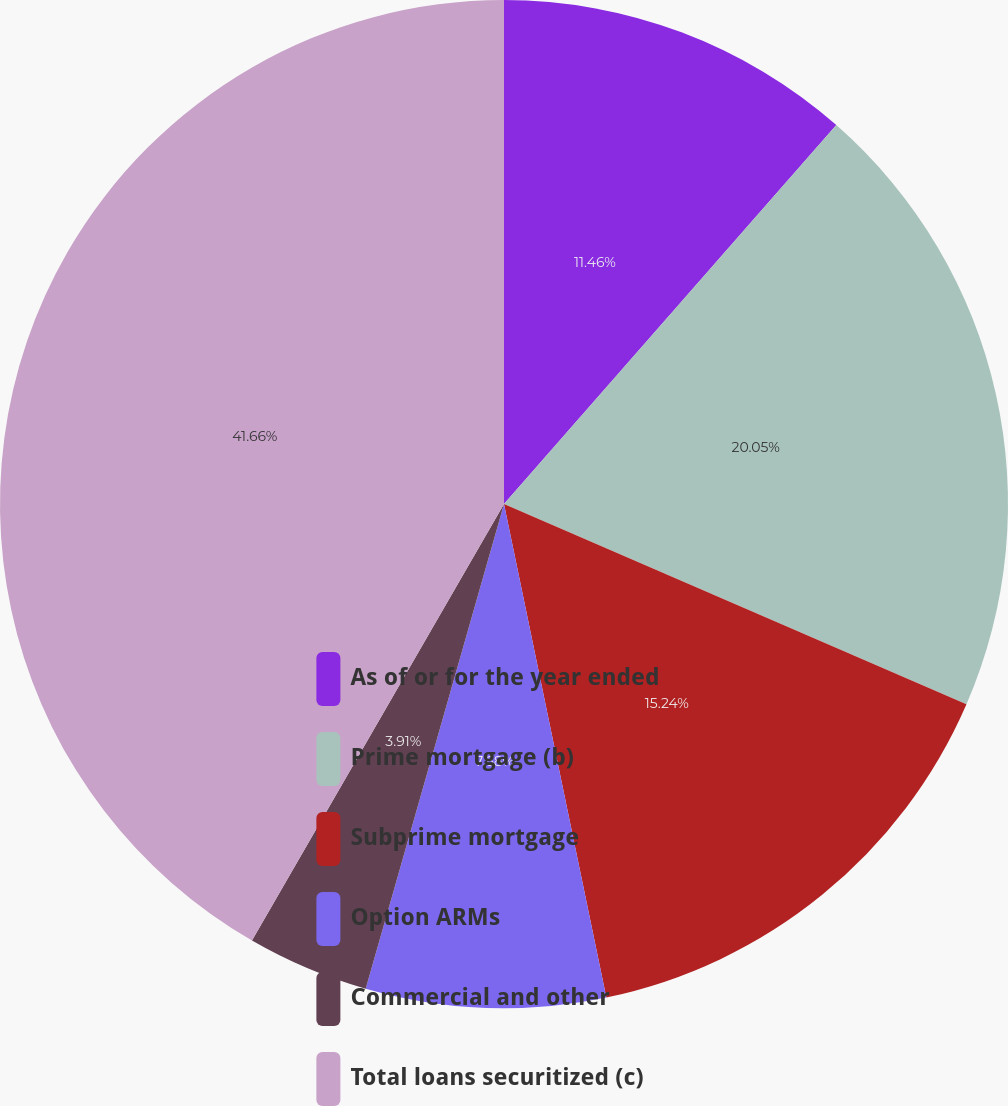<chart> <loc_0><loc_0><loc_500><loc_500><pie_chart><fcel>As of or for the year ended<fcel>Prime mortgage (b)<fcel>Subprime mortgage<fcel>Option ARMs<fcel>Commercial and other<fcel>Total loans securitized (c)<nl><fcel>11.46%<fcel>20.05%<fcel>15.24%<fcel>7.68%<fcel>3.91%<fcel>41.67%<nl></chart> 